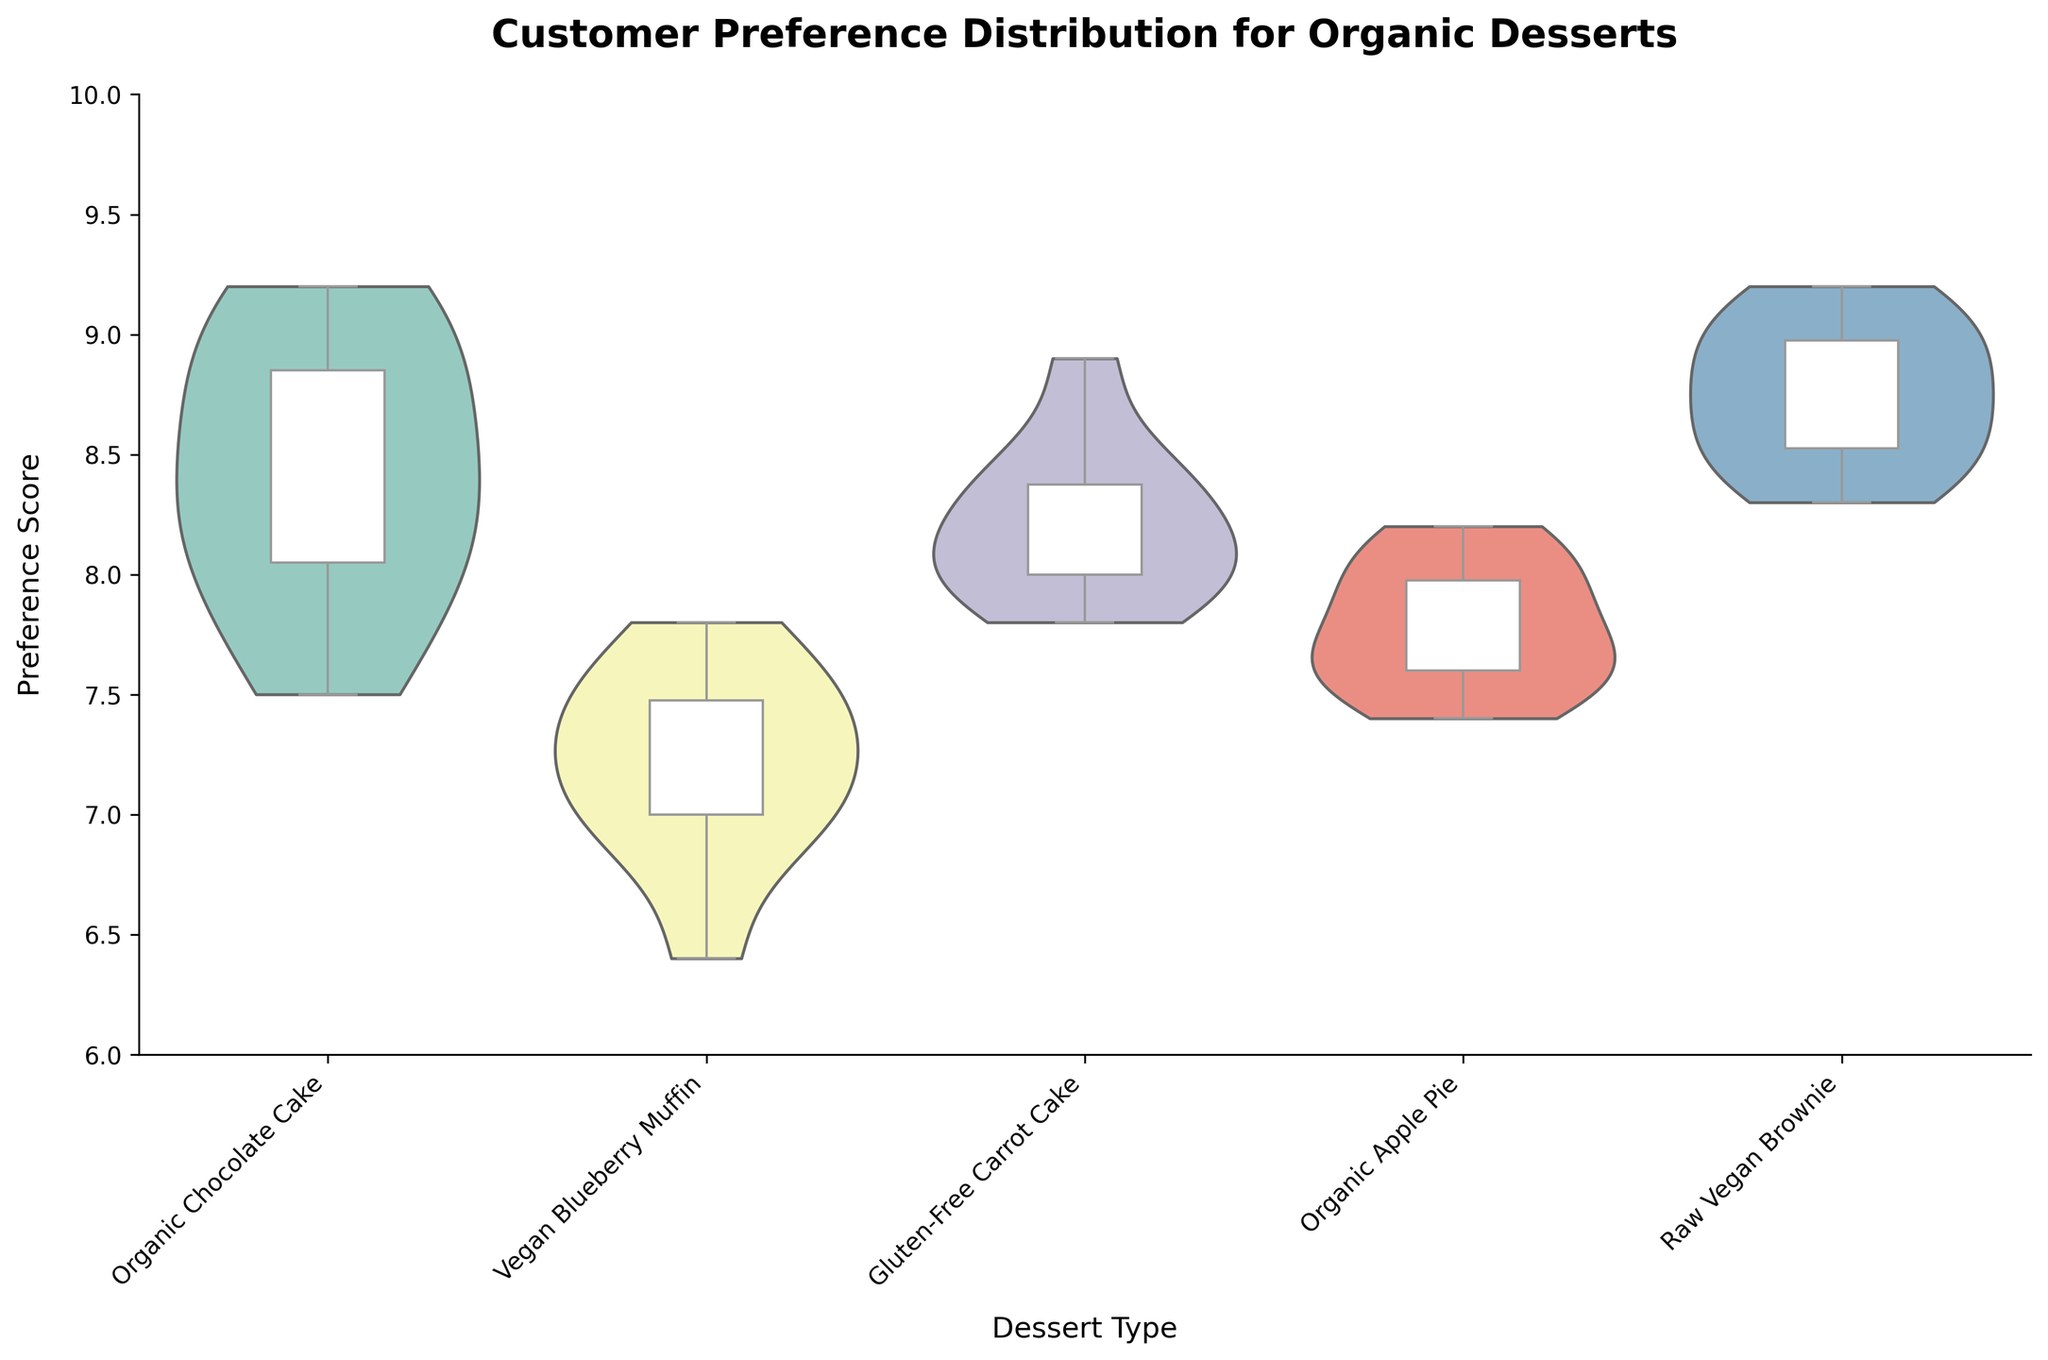What are the different dessert types represented in the chart? The title and the x-axis label (Dessert Type) provide information on the different dessert types. From the chart, you can read the dessert types listed along the x-axis.
Answer: Organic Chocolate Cake, Vegan Blueberry Muffin, Gluten-Free Carrot Cake, Organic Apple Pie, Raw Vegan Brownie What is the median preference score for the Organic Chocolate Cake? The median score is indicated by the line inside the white boxplot for the Organic Chocolate Cake section of the chart. From the boxplot, it is the central line within the box.
Answer: 8.3 Which dessert has the highest median preference score? By comparing the median lines across all boxplots in the violin chart, one can identify the highest median. Among all the desserts, the Raw Vegan Brownie has the highest median preference score.
Answer: Raw Vegan Brownie How does the spread of preference scores for the Vegan Blueberry Muffin compare to the Organic Apple Pie? This requires comparing the shapes of the violins and the spans from the minimum to the maximum whisker of the boxplots. The Vegan Blueberry Muffin's scores are more concentrated towards the lower end whereas the Organic Apple Pie has a more even distribution around its median.
Answer: Vegan Blueberry Muffin has a narrower spread with scores towards the lower end compared to Organic Apple Pie Which dessert has the smallest interquartile range (IQR) in the preference scores? The IQR is represented by the length of the white box in the boxplot. By visually comparing the lengths of these boxes, one can identify that the smallest IQR belongs to the Vegan Blueberry Muffin.
Answer: Vegan Blueberry Muffin Is there any dessert with a noticeable high preference score density around 9? By examining the densities of the violin shapes especially around the score of 9, one can see that the Raw Vegan Brownie has a noticeable density peak around this score.
Answer: Raw Vegan Brownie What is the range of preference scores for Gluten-Free Carrot Cake? The range is indicated by the ends of the whiskers on the boxplot which show the minimum and maximum scores. For Gluten-Free Carrot Cake, the range spans from around 7.8 to 8.9.
Answer: 7.8 to 8.9 Which dessert appears to have the most uniform distribution of preference scores? By looking at the violin shapes indicating the distribution of scores, the Organic Chocolate Cake appears to have a relatively uniform distribution compared to others.
Answer: Organic Chocolate Cake How do the median preference scores of Vegan Blueberry Muffin and Organic Apple Pie compare? Inspect the central lines of their respective boxplots. The median score for Vegan Blueberry Muffin is lower than that for Organic Apple Pie.
Answer: The median for Vegan Blueberry Muffin is lower than for Organic Apple Pie 